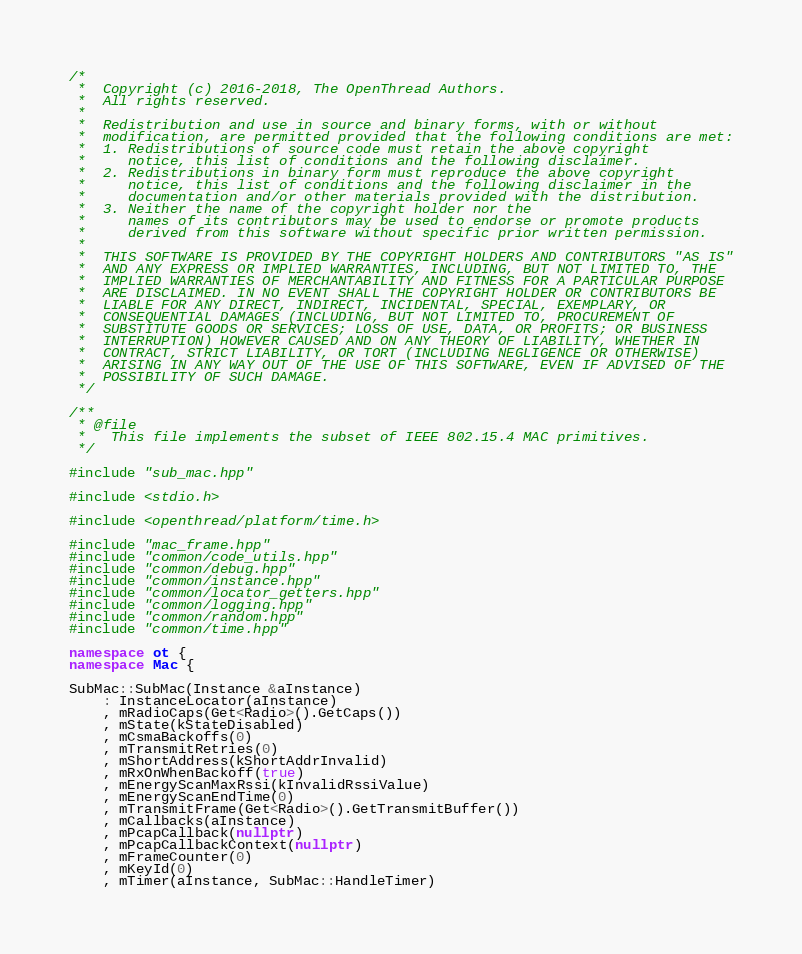<code> <loc_0><loc_0><loc_500><loc_500><_C++_>/*
 *  Copyright (c) 2016-2018, The OpenThread Authors.
 *  All rights reserved.
 *
 *  Redistribution and use in source and binary forms, with or without
 *  modification, are permitted provided that the following conditions are met:
 *  1. Redistributions of source code must retain the above copyright
 *     notice, this list of conditions and the following disclaimer.
 *  2. Redistributions in binary form must reproduce the above copyright
 *     notice, this list of conditions and the following disclaimer in the
 *     documentation and/or other materials provided with the distribution.
 *  3. Neither the name of the copyright holder nor the
 *     names of its contributors may be used to endorse or promote products
 *     derived from this software without specific prior written permission.
 *
 *  THIS SOFTWARE IS PROVIDED BY THE COPYRIGHT HOLDERS AND CONTRIBUTORS "AS IS"
 *  AND ANY EXPRESS OR IMPLIED WARRANTIES, INCLUDING, BUT NOT LIMITED TO, THE
 *  IMPLIED WARRANTIES OF MERCHANTABILITY AND FITNESS FOR A PARTICULAR PURPOSE
 *  ARE DISCLAIMED. IN NO EVENT SHALL THE COPYRIGHT HOLDER OR CONTRIBUTORS BE
 *  LIABLE FOR ANY DIRECT, INDIRECT, INCIDENTAL, SPECIAL, EXEMPLARY, OR
 *  CONSEQUENTIAL DAMAGES (INCLUDING, BUT NOT LIMITED TO, PROCUREMENT OF
 *  SUBSTITUTE GOODS OR SERVICES; LOSS OF USE, DATA, OR PROFITS; OR BUSINESS
 *  INTERRUPTION) HOWEVER CAUSED AND ON ANY THEORY OF LIABILITY, WHETHER IN
 *  CONTRACT, STRICT LIABILITY, OR TORT (INCLUDING NEGLIGENCE OR OTHERWISE)
 *  ARISING IN ANY WAY OUT OF THE USE OF THIS SOFTWARE, EVEN IF ADVISED OF THE
 *  POSSIBILITY OF SUCH DAMAGE.
 */

/**
 * @file
 *   This file implements the subset of IEEE 802.15.4 MAC primitives.
 */

#include "sub_mac.hpp"

#include <stdio.h>

#include <openthread/platform/time.h>

#include "mac_frame.hpp"
#include "common/code_utils.hpp"
#include "common/debug.hpp"
#include "common/instance.hpp"
#include "common/locator_getters.hpp"
#include "common/logging.hpp"
#include "common/random.hpp"
#include "common/time.hpp"

namespace ot {
namespace Mac {

SubMac::SubMac(Instance &aInstance)
    : InstanceLocator(aInstance)
    , mRadioCaps(Get<Radio>().GetCaps())
    , mState(kStateDisabled)
    , mCsmaBackoffs(0)
    , mTransmitRetries(0)
    , mShortAddress(kShortAddrInvalid)
    , mRxOnWhenBackoff(true)
    , mEnergyScanMaxRssi(kInvalidRssiValue)
    , mEnergyScanEndTime(0)
    , mTransmitFrame(Get<Radio>().GetTransmitBuffer())
    , mCallbacks(aInstance)
    , mPcapCallback(nullptr)
    , mPcapCallbackContext(nullptr)
    , mFrameCounter(0)
    , mKeyId(0)
    , mTimer(aInstance, SubMac::HandleTimer)</code> 